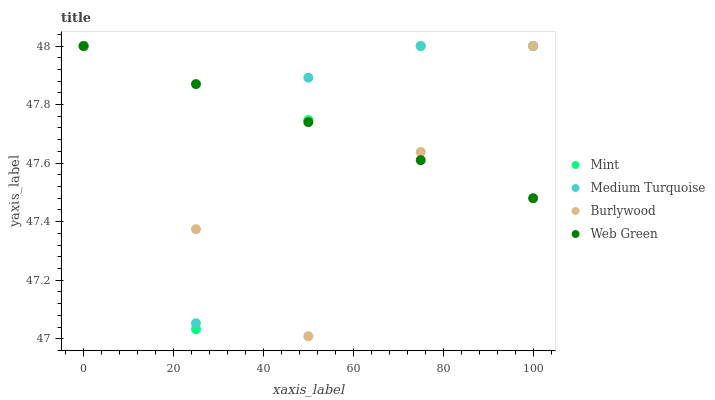Does Burlywood have the minimum area under the curve?
Answer yes or no. Yes. Does Web Green have the maximum area under the curve?
Answer yes or no. Yes. Does Mint have the minimum area under the curve?
Answer yes or no. No. Does Mint have the maximum area under the curve?
Answer yes or no. No. Is Web Green the smoothest?
Answer yes or no. Yes. Is Medium Turquoise the roughest?
Answer yes or no. Yes. Is Mint the smoothest?
Answer yes or no. No. Is Mint the roughest?
Answer yes or no. No. Does Burlywood have the lowest value?
Answer yes or no. Yes. Does Mint have the lowest value?
Answer yes or no. No. Does Medium Turquoise have the highest value?
Answer yes or no. Yes. Does Burlywood intersect Mint?
Answer yes or no. Yes. Is Burlywood less than Mint?
Answer yes or no. No. Is Burlywood greater than Mint?
Answer yes or no. No. 